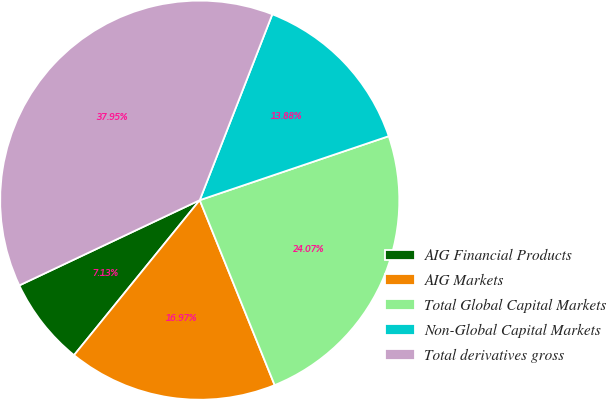Convert chart to OTSL. <chart><loc_0><loc_0><loc_500><loc_500><pie_chart><fcel>AIG Financial Products<fcel>AIG Markets<fcel>Total Global Capital Markets<fcel>Non-Global Capital Markets<fcel>Total derivatives gross<nl><fcel>7.13%<fcel>16.97%<fcel>24.07%<fcel>13.88%<fcel>37.95%<nl></chart> 